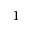Convert formula to latex. <formula><loc_0><loc_0><loc_500><loc_500>1</formula> 